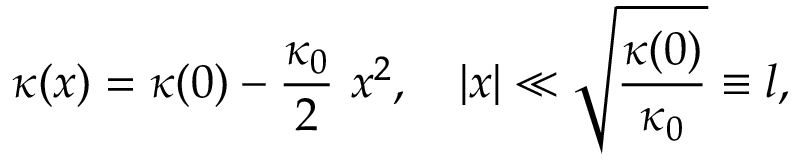<formula> <loc_0><loc_0><loc_500><loc_500>\kappa ( x ) = \kappa ( 0 ) - \frac { \kappa _ { 0 } } { 2 } x ^ { 2 } , | x | \ll \sqrt { \frac { \kappa ( 0 ) } { \kappa _ { 0 } } } \equiv l ,</formula> 